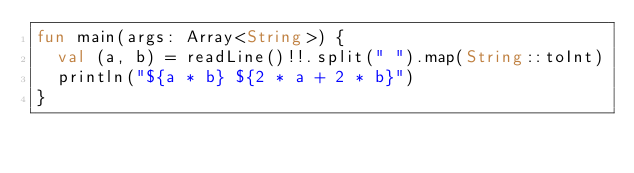<code> <loc_0><loc_0><loc_500><loc_500><_Kotlin_>fun main(args: Array<String>) {
  val (a, b) = readLine()!!.split(" ").map(String::toInt)
  println("${a * b} ${2 * a + 2 * b}")
}
</code> 